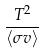Convert formula to latex. <formula><loc_0><loc_0><loc_500><loc_500>\frac { T ^ { 2 } } { \langle \sigma v \rangle }</formula> 